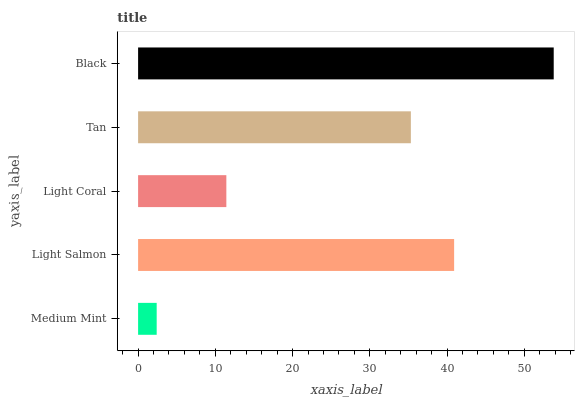Is Medium Mint the minimum?
Answer yes or no. Yes. Is Black the maximum?
Answer yes or no. Yes. Is Light Salmon the minimum?
Answer yes or no. No. Is Light Salmon the maximum?
Answer yes or no. No. Is Light Salmon greater than Medium Mint?
Answer yes or no. Yes. Is Medium Mint less than Light Salmon?
Answer yes or no. Yes. Is Medium Mint greater than Light Salmon?
Answer yes or no. No. Is Light Salmon less than Medium Mint?
Answer yes or no. No. Is Tan the high median?
Answer yes or no. Yes. Is Tan the low median?
Answer yes or no. Yes. Is Light Salmon the high median?
Answer yes or no. No. Is Light Coral the low median?
Answer yes or no. No. 